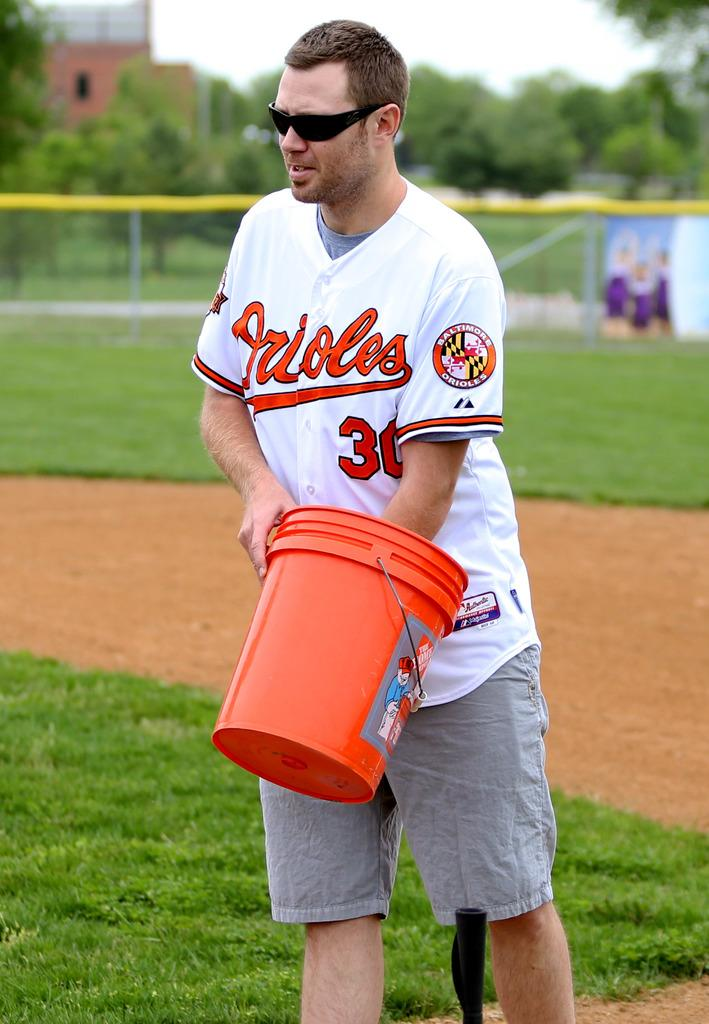<image>
Give a short and clear explanation of the subsequent image. A man is holding a bucket and he is wearing an Orioles jersey. 